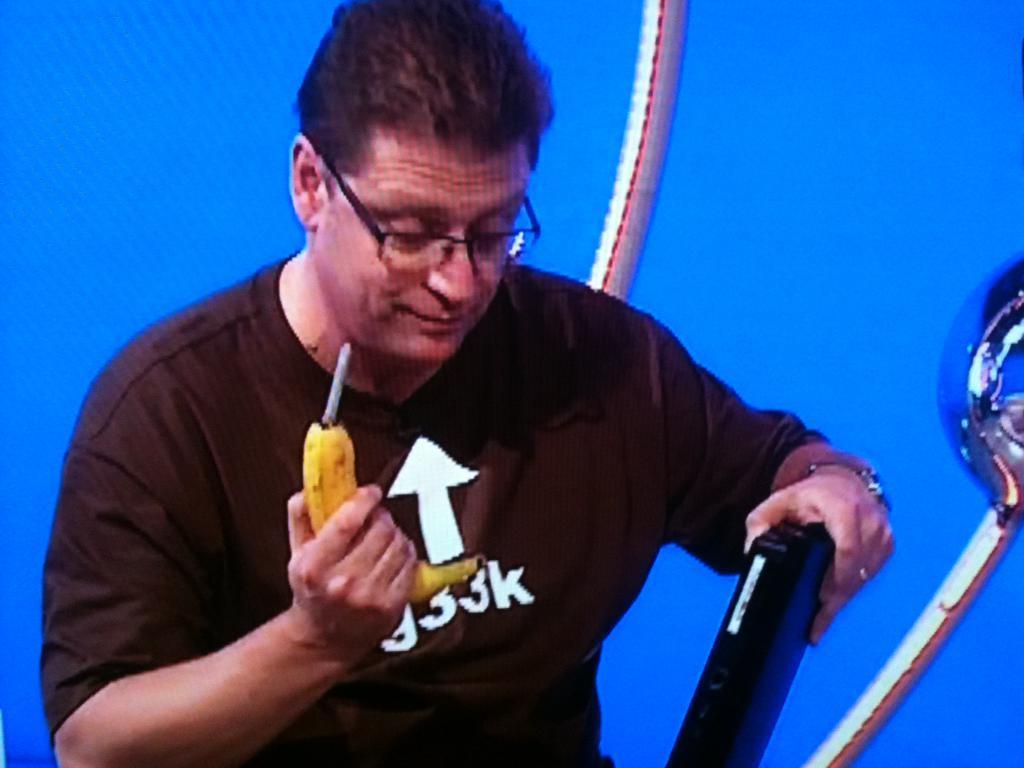Please provide a concise description of this image. In this image we can see a person holding few objects in his hand. There are few objects in the image. We can see the blue color background in the image. 